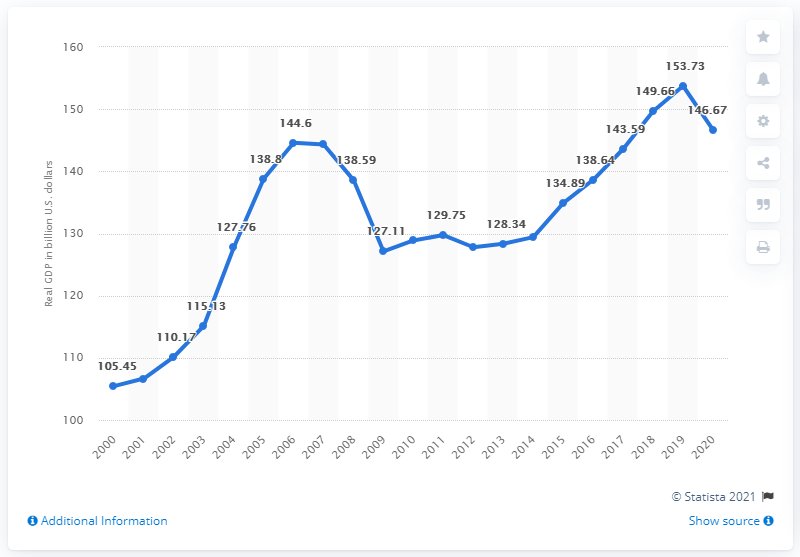Draw attention to some important aspects in this diagram. In 2018, the Gross Domestic Product (GDP) of Nevada was $153.73 billion. In 2020, Nevada's Gross Domestic Product (GDP) was 146.67. 